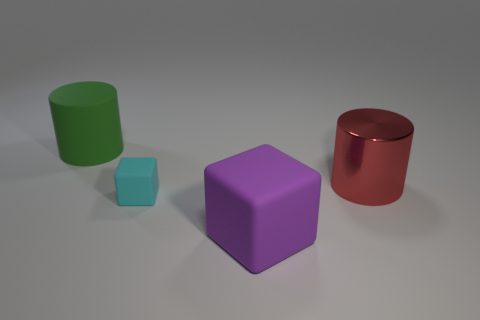Add 1 cyan objects. How many objects exist? 5 Add 3 big purple objects. How many big purple objects are left? 4 Add 2 tiny green metallic cylinders. How many tiny green metallic cylinders exist? 2 Subtract 0 red cubes. How many objects are left? 4 Subtract all tiny cyan rubber things. Subtract all tiny gray objects. How many objects are left? 3 